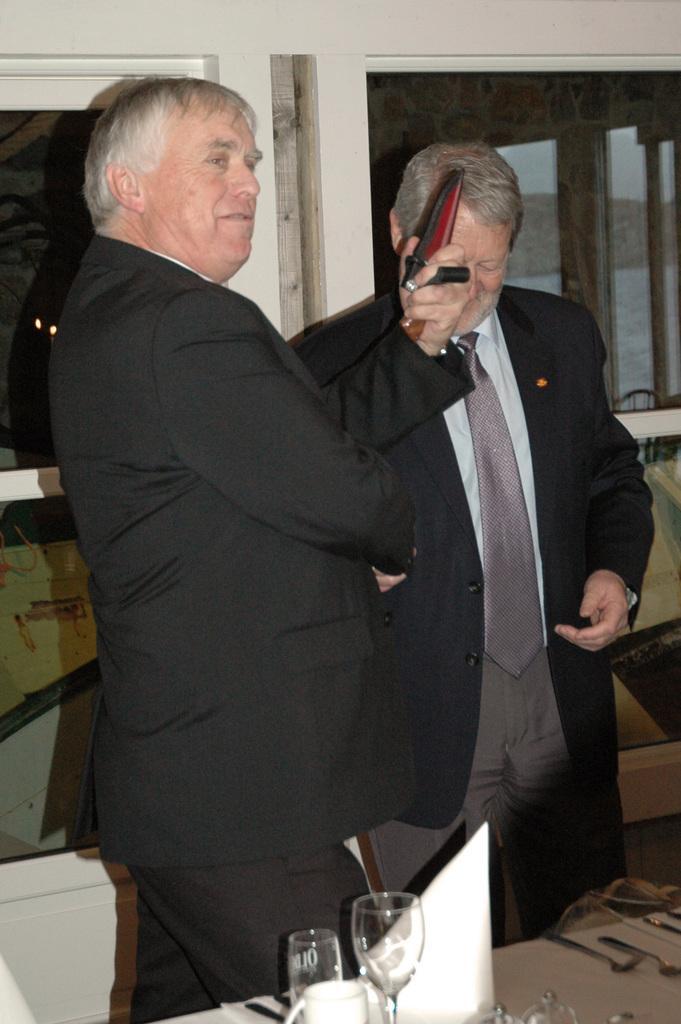Describe this image in one or two sentences. In this image we can see two people standing. They are wearing suits. The man standing on the left is holding an object. At the bottom there is a table and we can see glasses, napkins and spoons placed on the table. In the background there is a wall and windows. 